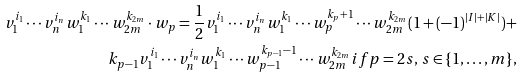<formula> <loc_0><loc_0><loc_500><loc_500>v _ { 1 } ^ { i _ { 1 } } \cdots v _ { n } ^ { i _ { n } } w _ { 1 } ^ { k _ { 1 } } \cdots w _ { 2 m } ^ { k _ { 2 m } } \cdot w _ { p } = \frac { 1 } { 2 } v _ { 1 } ^ { i _ { 1 } } \cdots v _ { n } ^ { i _ { n } } w _ { 1 } ^ { k _ { 1 } } \cdots w _ { p } ^ { k _ { p } + 1 } \cdots w _ { 2 m } ^ { k _ { 2 m } } ( 1 + ( - 1 ) ^ { | I | + | K | } ) + \\ k _ { p - 1 } v _ { 1 } ^ { i _ { 1 } } \cdots v _ { n } ^ { i _ { n } } w _ { 1 } ^ { k _ { 1 } } \cdots w _ { p - 1 } ^ { k _ { p - 1 } - 1 } \cdots w _ { 2 m } ^ { k _ { 2 m } } i f p = 2 s , \, s \in \{ 1 , \dots , m \} ,</formula> 